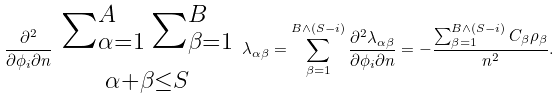<formula> <loc_0><loc_0><loc_500><loc_500>\frac { \partial ^ { 2 } } { \partial \phi _ { i } \partial n } \begin{array} { c } { \sum _ { \alpha = 1 } ^ { A } \sum _ { \beta = 1 } ^ { B } } \\ \null _ { \alpha + \beta \leq S } \end{array} \lambda _ { \alpha \beta } = \sum _ { \beta = 1 } ^ { B \wedge ( S - i ) } \frac { \partial ^ { 2 } \lambda _ { \alpha \beta } } { \partial \phi _ { i } \partial n } = - \frac { \sum _ { \beta = 1 } ^ { B \wedge ( S - i ) } C _ { \beta } \rho _ { \beta } } { n ^ { 2 } } .</formula> 